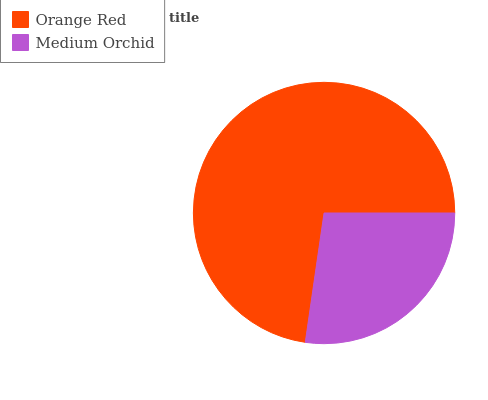Is Medium Orchid the minimum?
Answer yes or no. Yes. Is Orange Red the maximum?
Answer yes or no. Yes. Is Medium Orchid the maximum?
Answer yes or no. No. Is Orange Red greater than Medium Orchid?
Answer yes or no. Yes. Is Medium Orchid less than Orange Red?
Answer yes or no. Yes. Is Medium Orchid greater than Orange Red?
Answer yes or no. No. Is Orange Red less than Medium Orchid?
Answer yes or no. No. Is Orange Red the high median?
Answer yes or no. Yes. Is Medium Orchid the low median?
Answer yes or no. Yes. Is Medium Orchid the high median?
Answer yes or no. No. Is Orange Red the low median?
Answer yes or no. No. 